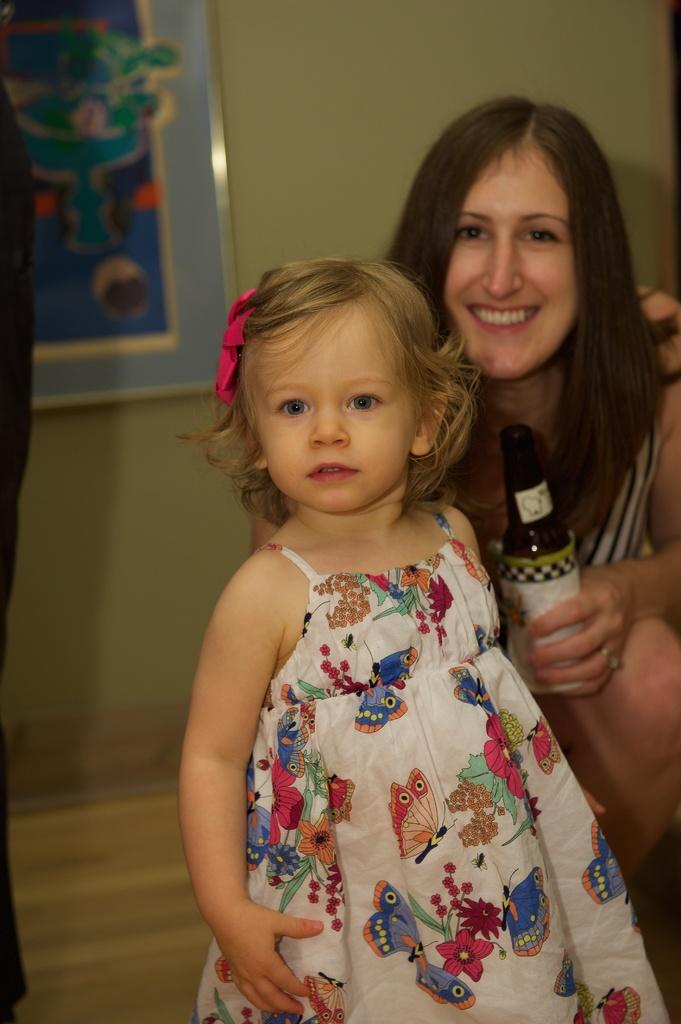Who is present in the image? There is a woman and a girl in the image. What is the woman holding in her hand? The woman is holding a bottle in her hand. What expressions do the woman and the girl have? The woman and the girl are both smiling. What is the girl wearing? The girl is wearing a beautiful dress. What can be seen in the background of the image? There is a wall with frames in the background of the image. What type of boundary can be seen between the woman and the girl in the image? There is no boundary visible between the woman and the girl in the image; they are standing close to each other. Is there a band performing in the image? There is no band present in the image. 